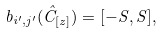<formula> <loc_0><loc_0><loc_500><loc_500>b _ { i ^ { \prime } , j ^ { \prime } } ( \hat { C } _ { [ z ] } ) = [ - S , S ] ,</formula> 